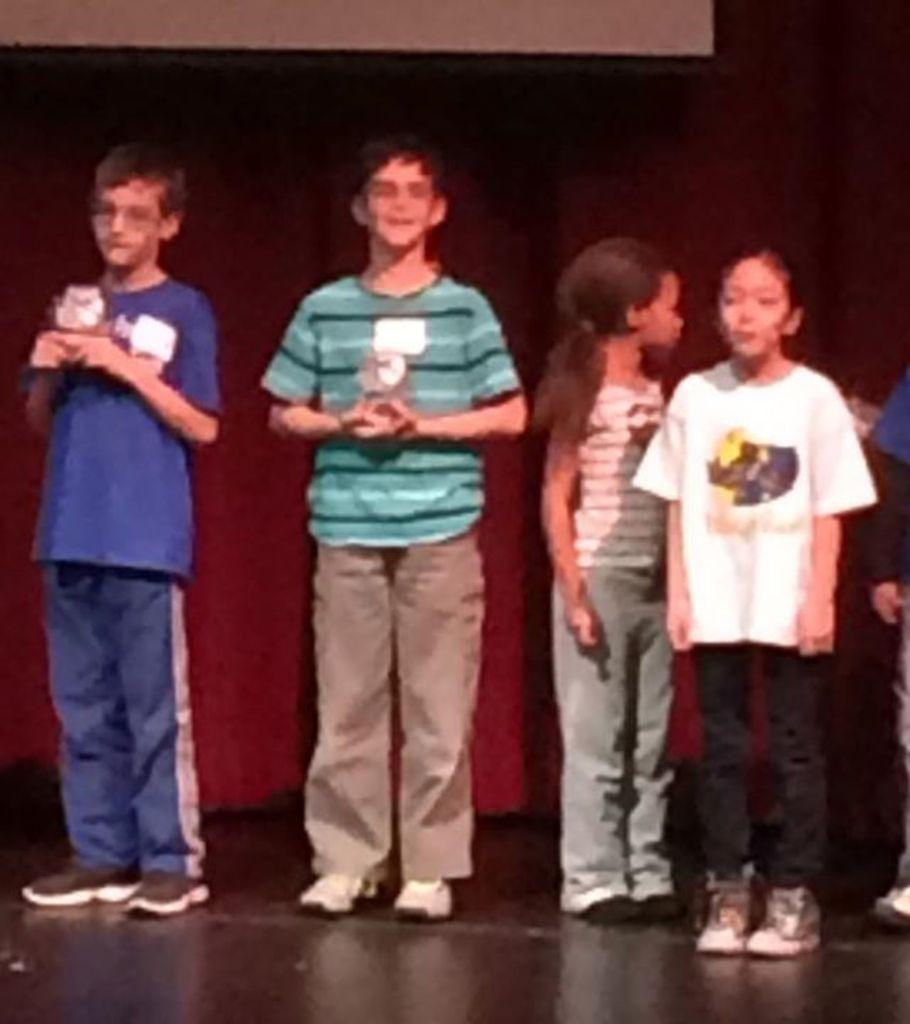What is the main subject in the middle of the image? There is a boy standing in the middle of the image. What is the boy wearing? The boy is wearing a shirt and trousers. Are there any other people in the image? Yes, there are two girls standing on the right side of the image. What type of laborer is the girl on the left side of the image? There is no girl on the left side of the image, and the image does not depict any laborers. 